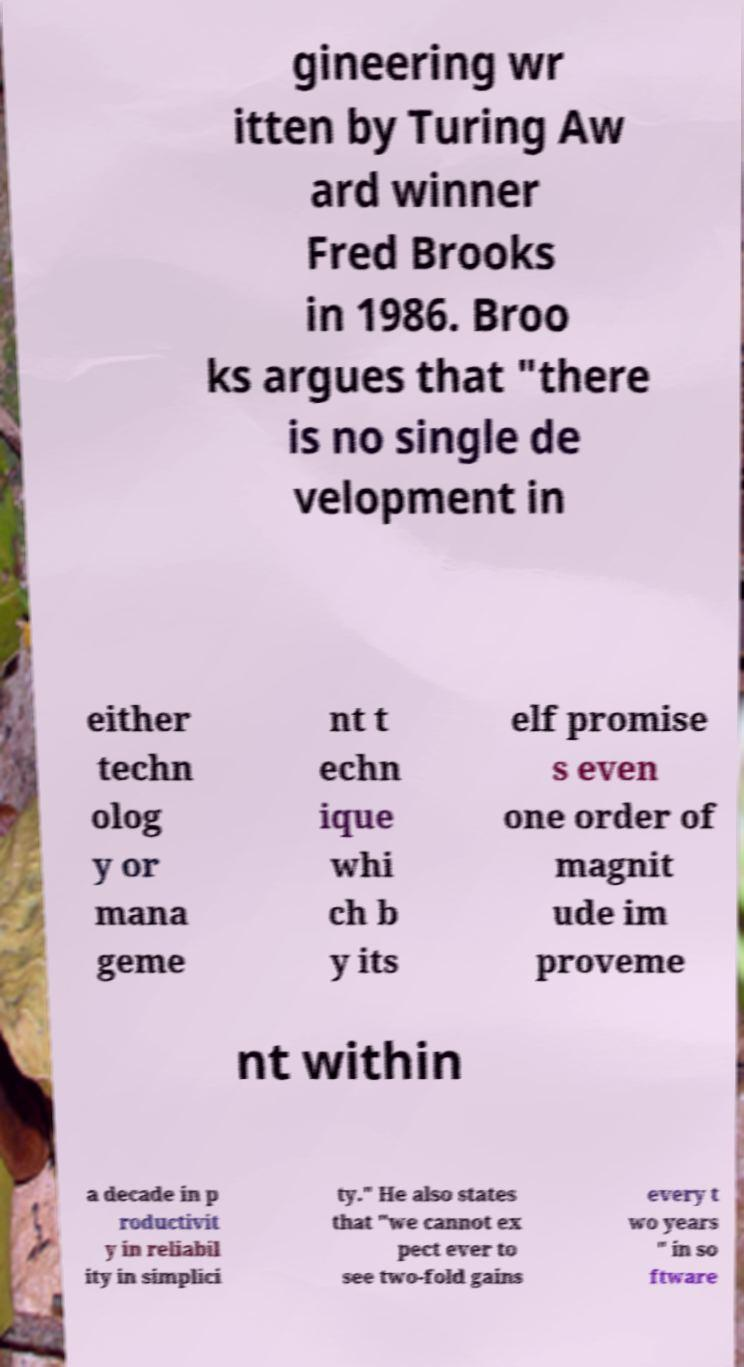I need the written content from this picture converted into text. Can you do that? gineering wr itten by Turing Aw ard winner Fred Brooks in 1986. Broo ks argues that "there is no single de velopment in either techn olog y or mana geme nt t echn ique whi ch b y its elf promise s even one order of magnit ude im proveme nt within a decade in p roductivit y in reliabil ity in simplici ty." He also states that "we cannot ex pect ever to see two-fold gains every t wo years " in so ftware 